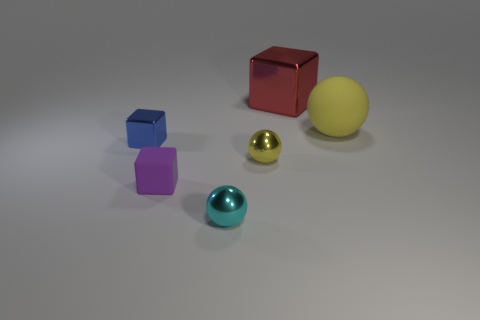There is a small object that is the same color as the large rubber ball; what is its material?
Your answer should be compact. Metal. How many objects are either cubes that are behind the yellow rubber object or large green rubber spheres?
Your answer should be compact. 1. How many small cubes are in front of the tiny metallic thing in front of the cube that is in front of the blue object?
Offer a terse response. 0. Are there any other things that are the same size as the purple object?
Give a very brief answer. Yes. The matte thing that is behind the small metallic thing behind the small yellow sphere in front of the small blue shiny object is what shape?
Give a very brief answer. Sphere. How many other objects are there of the same color as the big shiny thing?
Offer a terse response. 0. There is a rubber thing on the left side of the yellow thing behind the small yellow metal thing; what is its shape?
Keep it short and to the point. Cube. There is a red object; how many tiny yellow metallic objects are to the right of it?
Keep it short and to the point. 0. Is there a blue cube that has the same material as the purple thing?
Your answer should be compact. No. There is a ball that is the same size as the red object; what is its material?
Offer a very short reply. Rubber. 